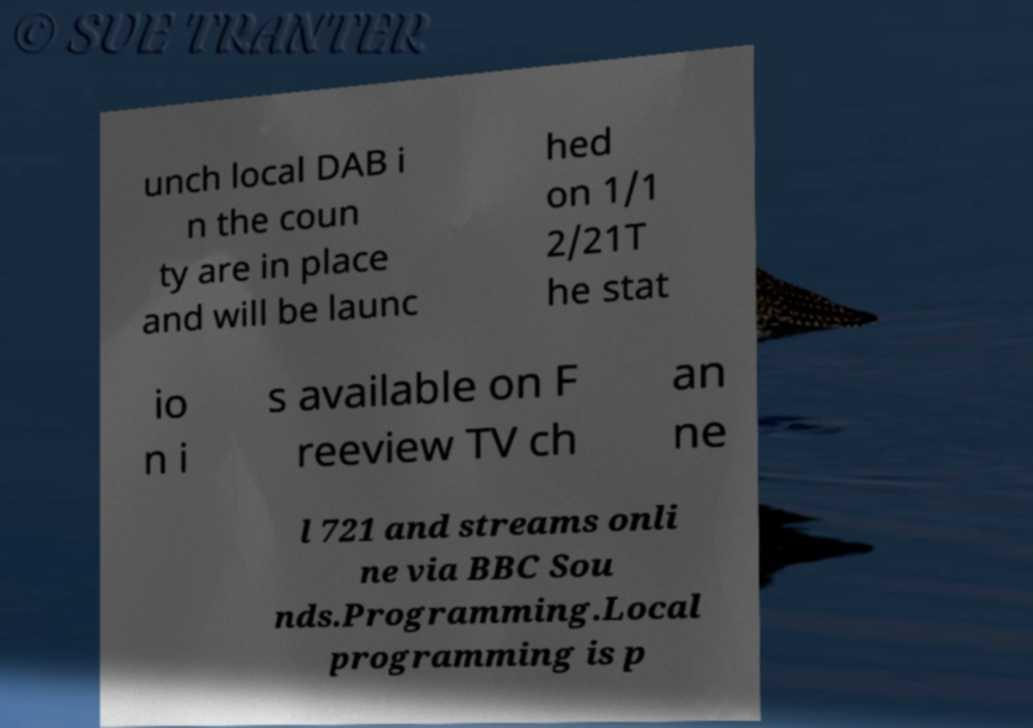Can you accurately transcribe the text from the provided image for me? unch local DAB i n the coun ty are in place and will be launc hed on 1/1 2/21T he stat io n i s available on F reeview TV ch an ne l 721 and streams onli ne via BBC Sou nds.Programming.Local programming is p 